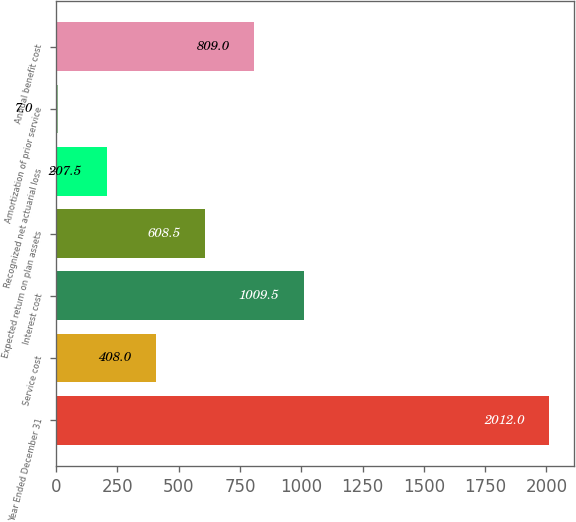Convert chart to OTSL. <chart><loc_0><loc_0><loc_500><loc_500><bar_chart><fcel>Year Ended December 31<fcel>Service cost<fcel>Interest cost<fcel>Expected return on plan assets<fcel>Recognized net actuarial loss<fcel>Amortization of prior service<fcel>Annual benefit cost<nl><fcel>2012<fcel>408<fcel>1009.5<fcel>608.5<fcel>207.5<fcel>7<fcel>809<nl></chart> 